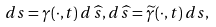<formula> <loc_0><loc_0><loc_500><loc_500>d s = \gamma ( \cdot , t ) \, d \, \widehat { s } , d \, \widehat { s } = \widetilde { \gamma } ( \cdot , t ) \, d s ,</formula> 